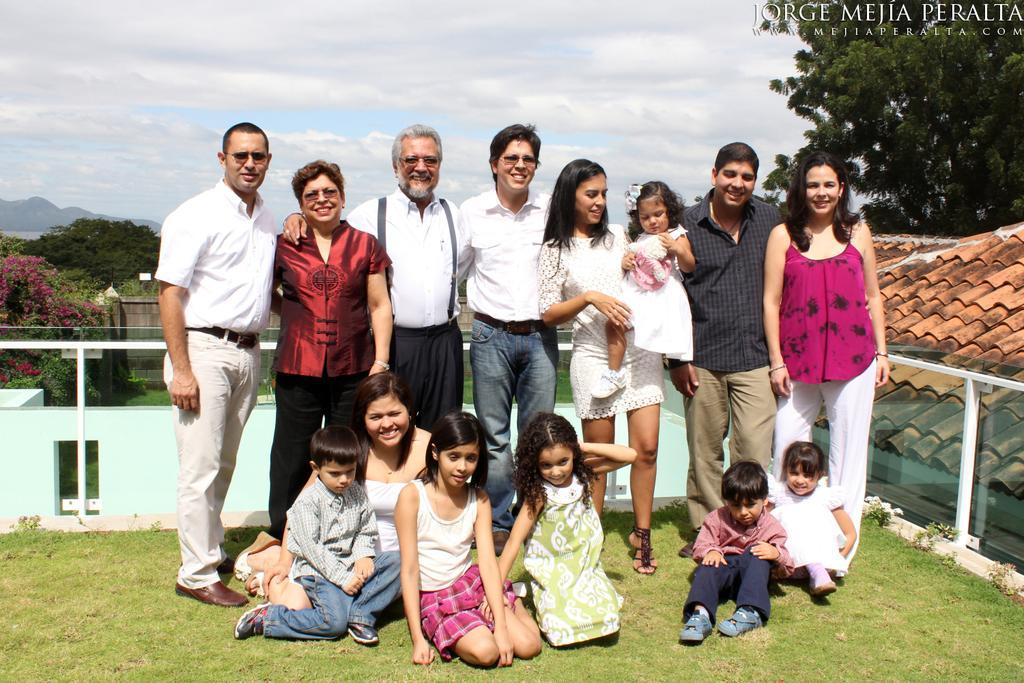Describe this image in one or two sentences. In this image children are sitting on the surface of the grass. Behind them few people are standing. At the right side of the image there is a building. At the background there are trees and sky. 